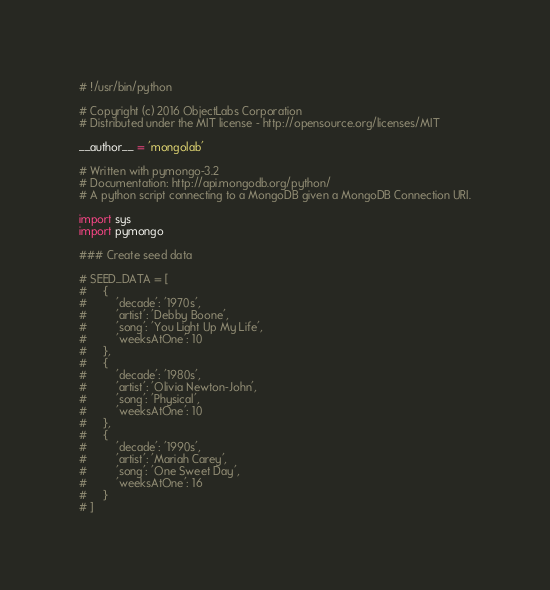<code> <loc_0><loc_0><loc_500><loc_500><_Python_># !/usr/bin/python

# Copyright (c) 2016 ObjectLabs Corporation
# Distributed under the MIT license - http://opensource.org/licenses/MIT

__author__ = 'mongolab'

# Written with pymongo-3.2
# Documentation: http://api.mongodb.org/python/
# A python script connecting to a MongoDB given a MongoDB Connection URI.

import sys
import pymongo

### Create seed data

# SEED_DATA = [
#     {
#         'decade': '1970s',
#         'artist': 'Debby Boone',
#         'song': 'You Light Up My Life',
#         'weeksAtOne': 10
#     },
#     {
#         'decade': '1980s',
#         'artist': 'Olivia Newton-John',
#         'song': 'Physical',
#         'weeksAtOne': 10
#     },
#     {
#         'decade': '1990s',
#         'artist': 'Mariah Carey',
#         'song': 'One Sweet Day',
#         'weeksAtOne': 16
#     }
# ]
</code> 